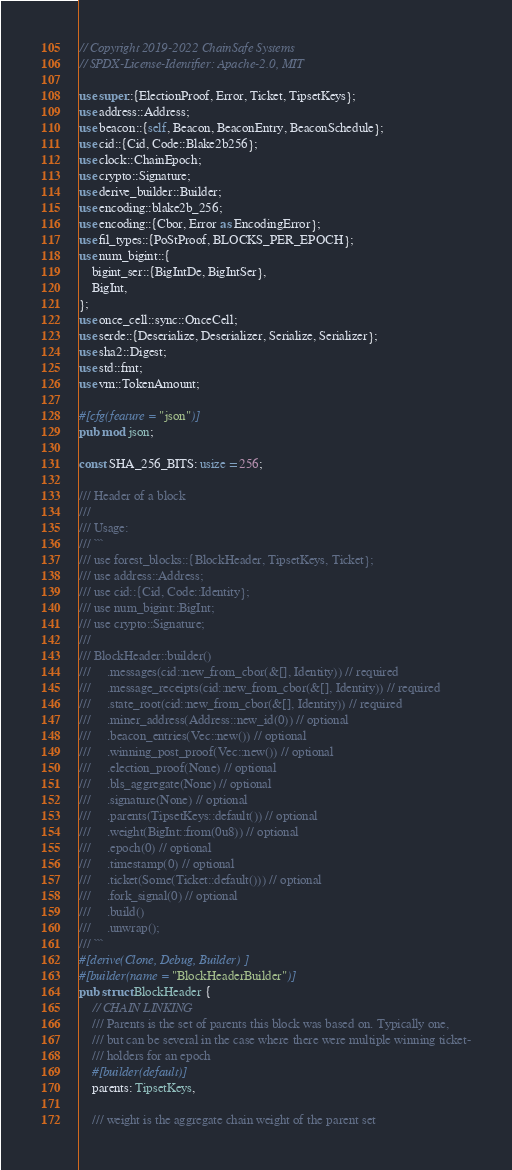Convert code to text. <code><loc_0><loc_0><loc_500><loc_500><_Rust_>// Copyright 2019-2022 ChainSafe Systems
// SPDX-License-Identifier: Apache-2.0, MIT

use super::{ElectionProof, Error, Ticket, TipsetKeys};
use address::Address;
use beacon::{self, Beacon, BeaconEntry, BeaconSchedule};
use cid::{Cid, Code::Blake2b256};
use clock::ChainEpoch;
use crypto::Signature;
use derive_builder::Builder;
use encoding::blake2b_256;
use encoding::{Cbor, Error as EncodingError};
use fil_types::{PoStProof, BLOCKS_PER_EPOCH};
use num_bigint::{
    bigint_ser::{BigIntDe, BigIntSer},
    BigInt,
};
use once_cell::sync::OnceCell;
use serde::{Deserialize, Deserializer, Serialize, Serializer};
use sha2::Digest;
use std::fmt;
use vm::TokenAmount;

#[cfg(feature = "json")]
pub mod json;

const SHA_256_BITS: usize = 256;

/// Header of a block
///
/// Usage:
/// ```
/// use forest_blocks::{BlockHeader, TipsetKeys, Ticket};
/// use address::Address;
/// use cid::{Cid, Code::Identity};
/// use num_bigint::BigInt;
/// use crypto::Signature;
///
/// BlockHeader::builder()
///     .messages(cid::new_from_cbor(&[], Identity)) // required
///     .message_receipts(cid::new_from_cbor(&[], Identity)) // required
///     .state_root(cid::new_from_cbor(&[], Identity)) // required
///     .miner_address(Address::new_id(0)) // optional
///     .beacon_entries(Vec::new()) // optional
///     .winning_post_proof(Vec::new()) // optional
///     .election_proof(None) // optional
///     .bls_aggregate(None) // optional
///     .signature(None) // optional
///     .parents(TipsetKeys::default()) // optional
///     .weight(BigInt::from(0u8)) // optional
///     .epoch(0) // optional
///     .timestamp(0) // optional
///     .ticket(Some(Ticket::default())) // optional
///     .fork_signal(0) // optional
///     .build()
///     .unwrap();
/// ```
#[derive(Clone, Debug, Builder)]
#[builder(name = "BlockHeaderBuilder")]
pub struct BlockHeader {
    // CHAIN LINKING
    /// Parents is the set of parents this block was based on. Typically one,
    /// but can be several in the case where there were multiple winning ticket-
    /// holders for an epoch
    #[builder(default)]
    parents: TipsetKeys,

    /// weight is the aggregate chain weight of the parent set</code> 